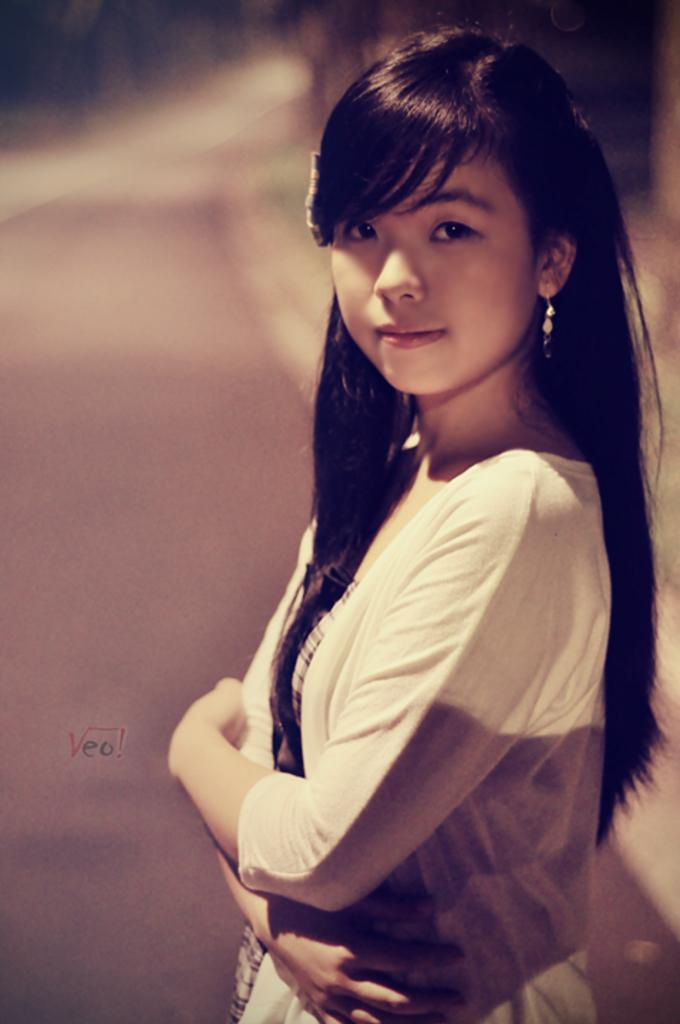Who is the main subject in the image? There is a woman in the image. Where is the woman positioned in the image? The woman is standing in the middle of the image. What expression does the woman have? The woman is smiling. Can you describe the background of the image? The background of the image is blurred. What type of vessel is the woman holding in the image? There is no vessel present in the image; the woman is not holding anything. What type of celery can be seen in the background of the image? There is no celery present in the image; the background is blurred and does not show any specific objects. 